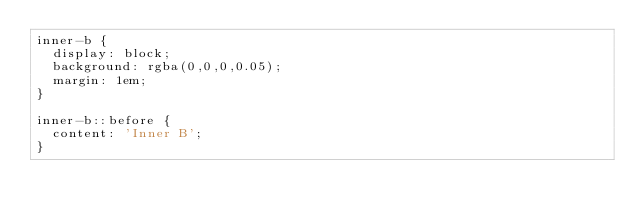Convert code to text. <code><loc_0><loc_0><loc_500><loc_500><_CSS_>inner-b {
  display: block;
  background: rgba(0,0,0,0.05);
  margin: 1em;
}

inner-b::before {
  content: 'Inner B';
}
</code> 